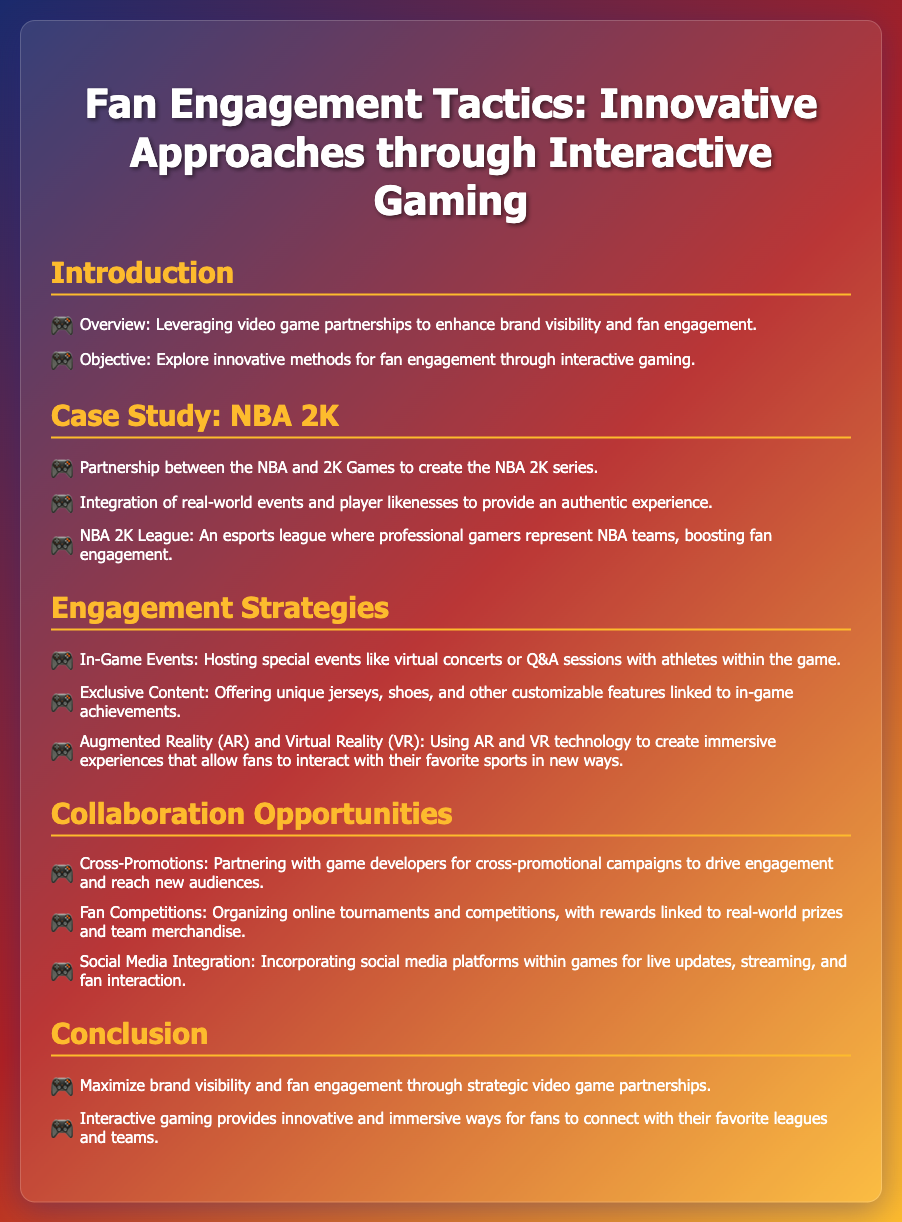What is the main objective of the presentation? The objective stated in the document is to explore innovative methods for fan engagement through interactive gaming.
Answer: Explore innovative methods for fan engagement through interactive gaming What video game series is mentioned as a case study? The document specifies the partnership between the NBA and 2K Games regarding the NBA 2K series.
Answer: NBA 2K series What type of league is the NBA 2K League? The document describes the NBA 2K League as an esports league where professional gamers represent NBA teams.
Answer: Esports league What is one type of exclusive content offered in the engagement strategies? The document lists unique jerseys as one type of exclusive content related to in-game achievements.
Answer: Unique jerseys What technology is used to create immersive experiences according to the engagement strategies? The document mentions AR (Augmented Reality) and VR (Virtual Reality) technology for immersive experiences.
Answer: AR and VR What is a method of collaboration mentioned in the document? The document refers to cross-promotional campaigns as a method of collaboration with game developers.
Answer: Cross-promotions What is one possible reward for fan competitions? According to the document, rewards for fan competitions are linked to real-world prizes and team merchandise.
Answer: Real-world prizes What is a recommended engagement tactic featuring athletes? Hosting special events like Q&A sessions with athletes is highlighted as a tactical engagement method.
Answer: Q&A sessions with athletes 